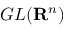Convert formula to latex. <formula><loc_0><loc_0><loc_500><loc_500>G L ( R ^ { n } )</formula> 